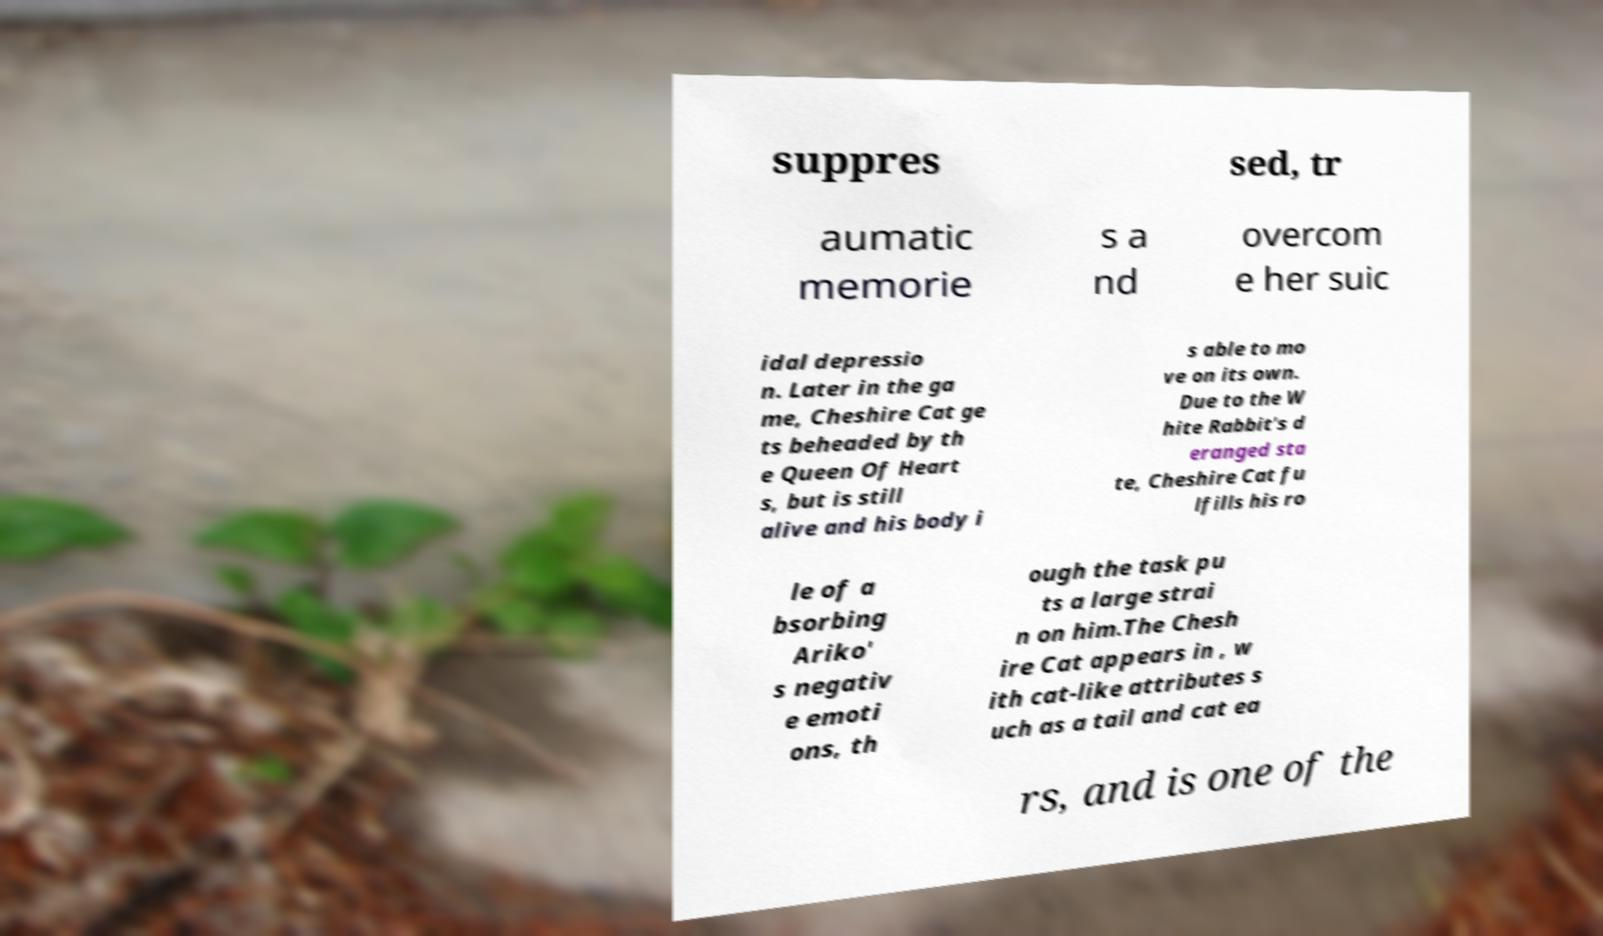Could you assist in decoding the text presented in this image and type it out clearly? suppres sed, tr aumatic memorie s a nd overcom e her suic idal depressio n. Later in the ga me, Cheshire Cat ge ts beheaded by th e Queen Of Heart s, but is still alive and his body i s able to mo ve on its own. Due to the W hite Rabbit's d eranged sta te, Cheshire Cat fu lfills his ro le of a bsorbing Ariko' s negativ e emoti ons, th ough the task pu ts a large strai n on him.The Chesh ire Cat appears in , w ith cat-like attributes s uch as a tail and cat ea rs, and is one of the 